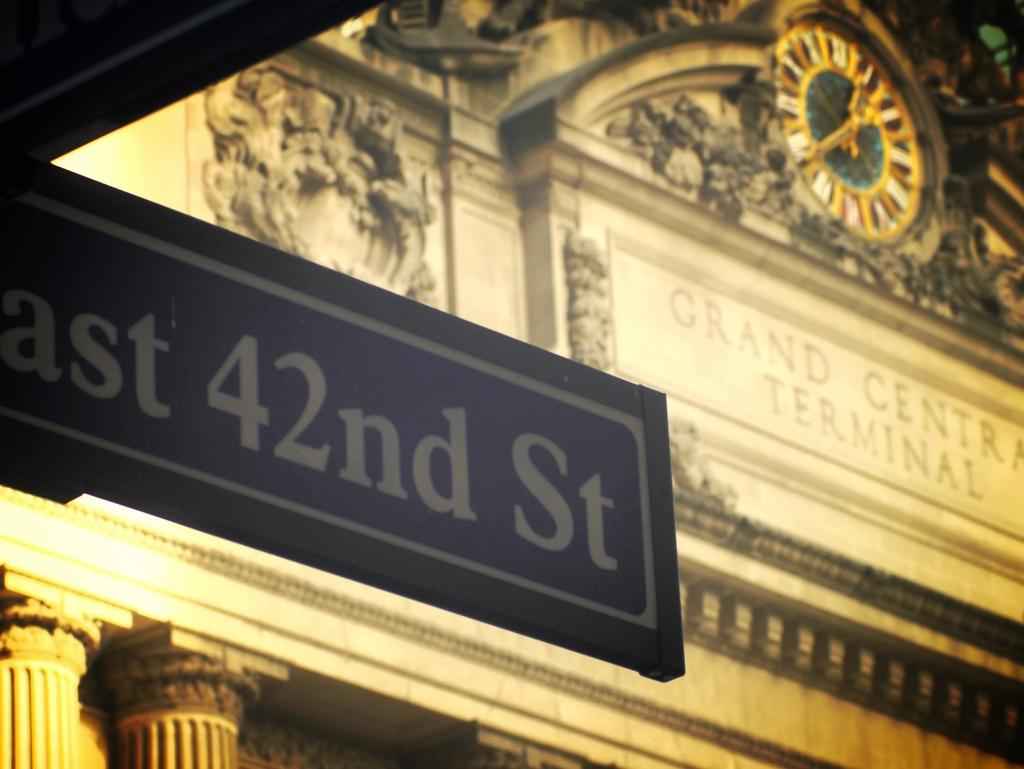Provide a one-sentence caption for the provided image. A sign with 42nd St is in front of a terminal. 